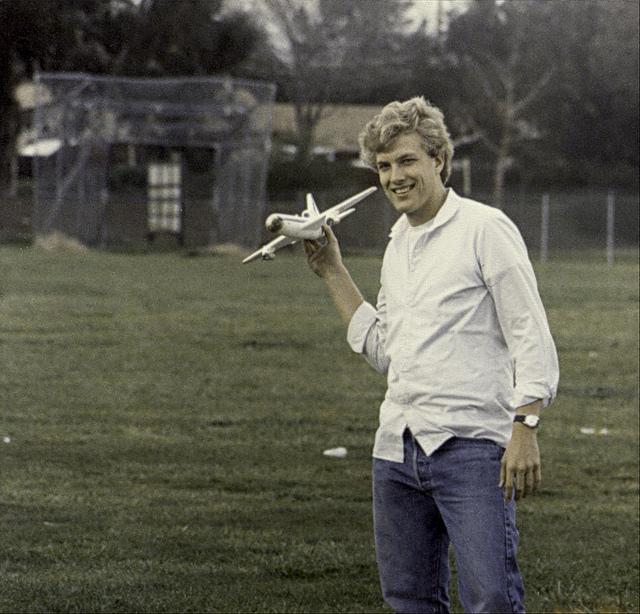What is the man doing?
Answer briefly. Flying toy plane. What is the boy wearing on his wrist?
Quick response, please. Watch. Is that a real airplane?
Quick response, please. No. What is the person holding in his hand?
Give a very brief answer. Plane. Is his shirt tucked in?
Give a very brief answer. No. 